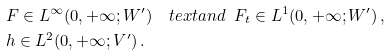<formula> <loc_0><loc_0><loc_500><loc_500>& F \in L ^ { \infty } ( 0 , + \infty ; W ^ { \prime } ) \quad t e x t { a n d } \ \ F _ { t } \in L ^ { 1 } ( 0 , + \infty ; W ^ { \prime } ) \, , \\ & h \in L ^ { 2 } ( 0 , + \infty ; V ^ { \prime } ) \, .</formula> 